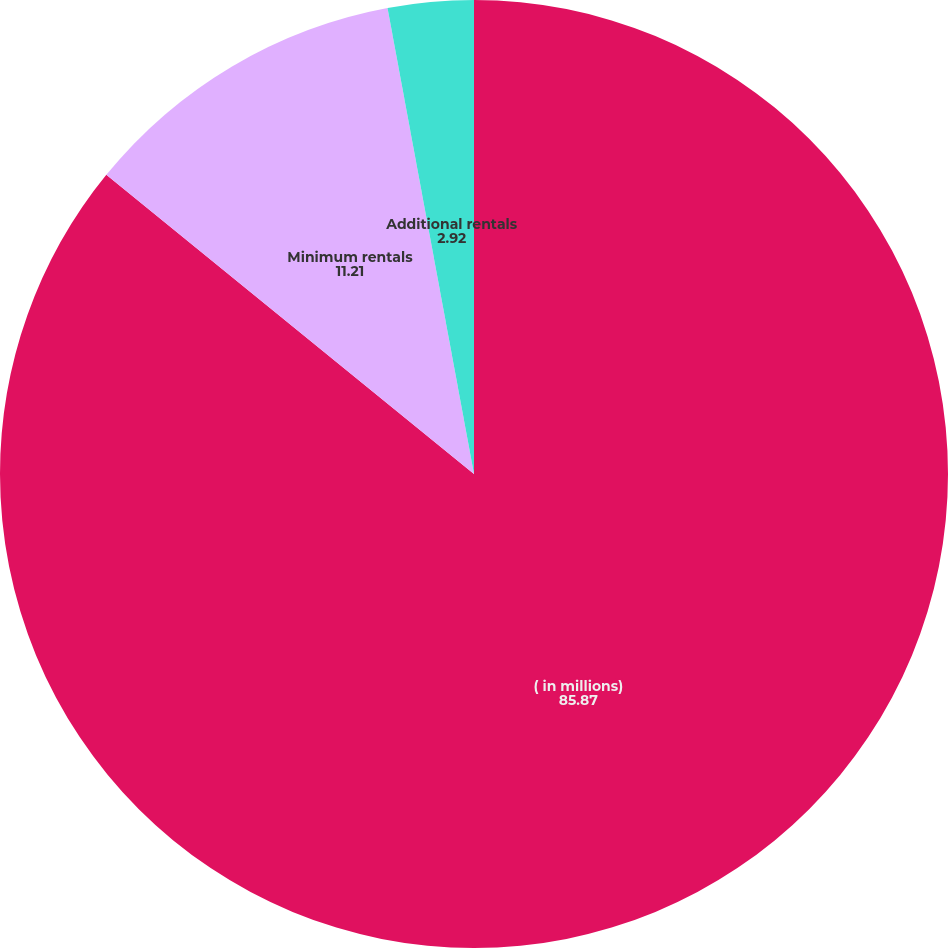Convert chart to OTSL. <chart><loc_0><loc_0><loc_500><loc_500><pie_chart><fcel>( in millions)<fcel>Minimum rentals<fcel>Additional rentals<nl><fcel>85.87%<fcel>11.21%<fcel>2.92%<nl></chart> 